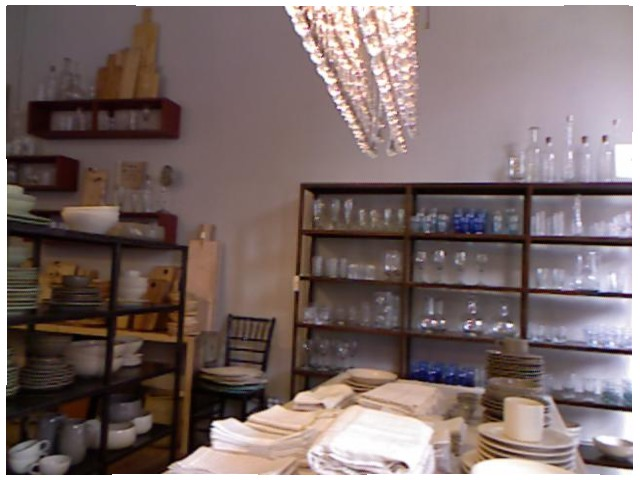<image>
Is the goblet on the shelf? Yes. Looking at the image, I can see the goblet is positioned on top of the shelf, with the shelf providing support. Is there a glass next to the wall? No. The glass is not positioned next to the wall. They are located in different areas of the scene. 